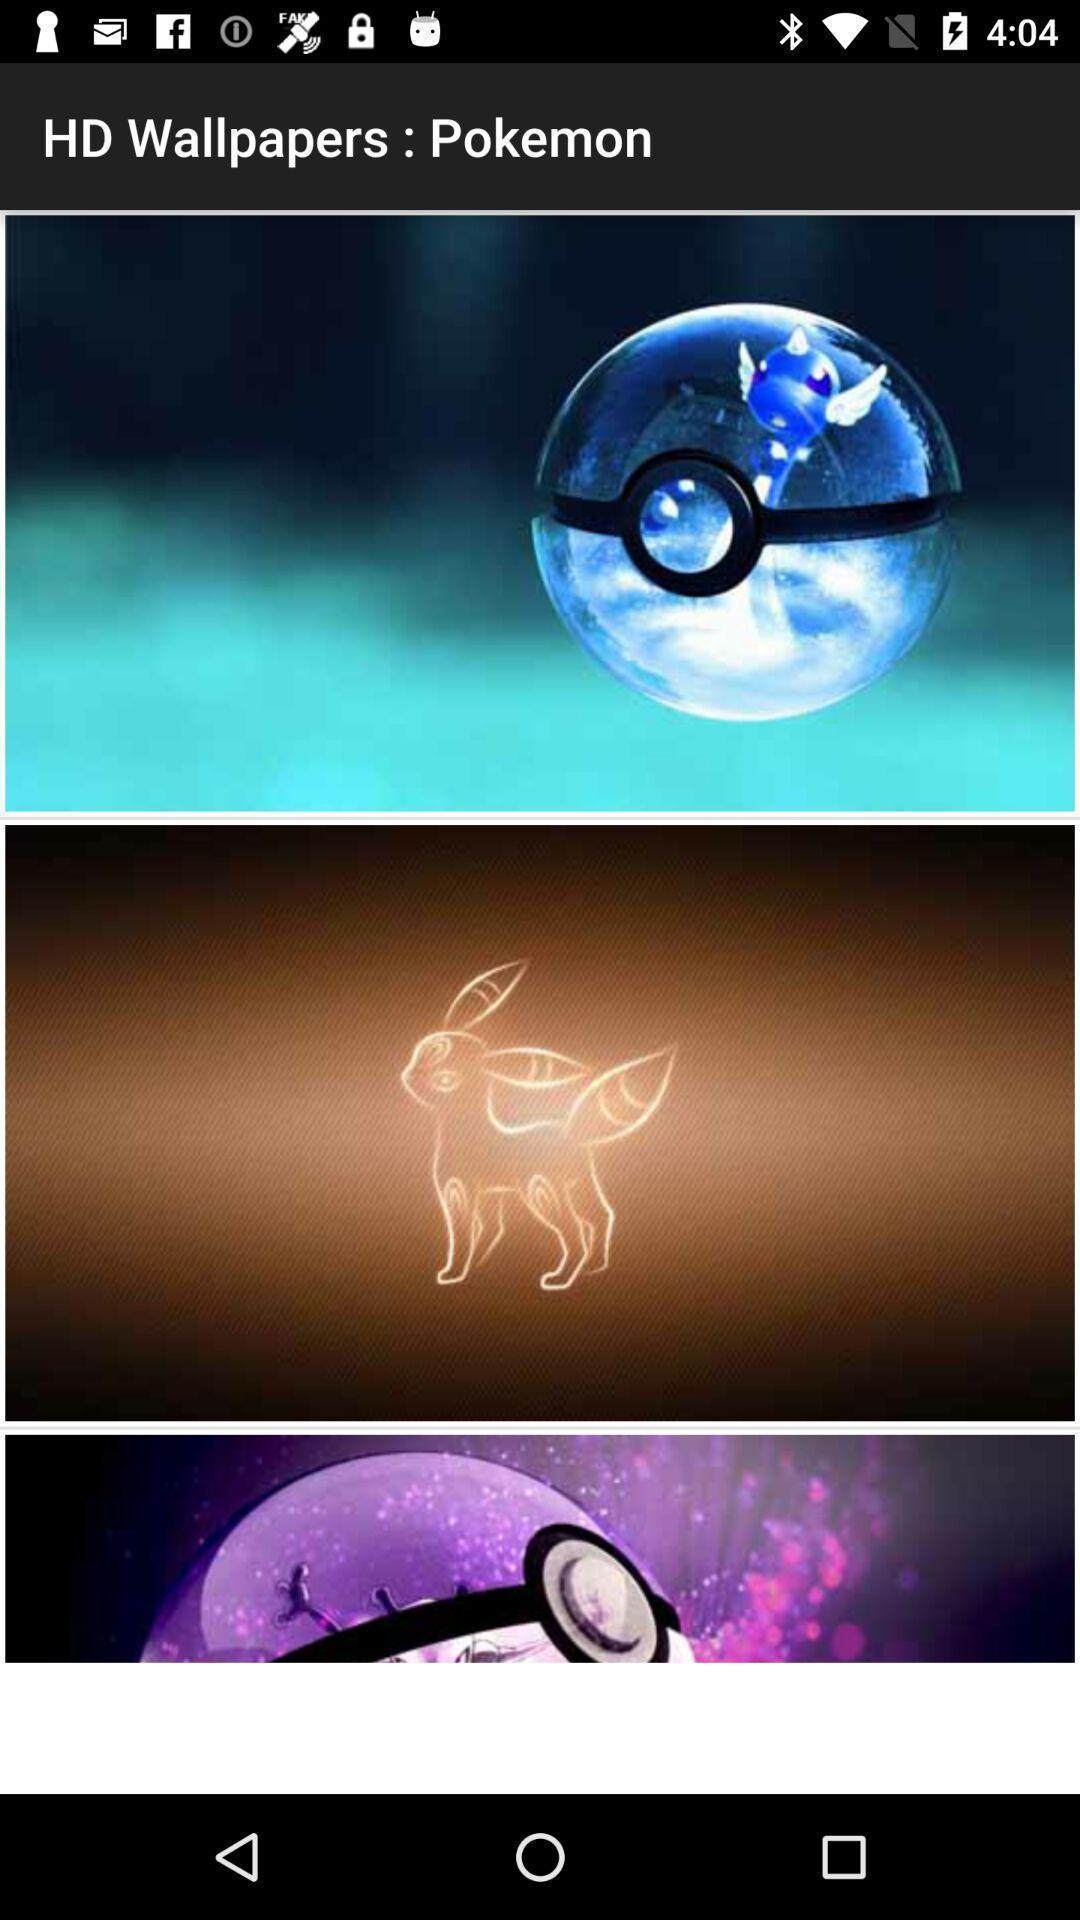Summarize the main components in this picture. Page displaying three different wallpapers. 